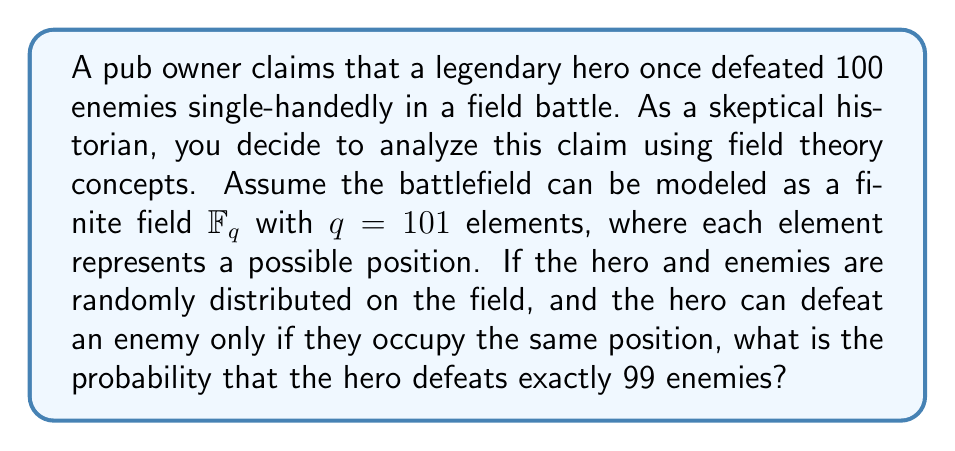Could you help me with this problem? Let's approach this step-by-step using concepts from field theory and probability:

1) The battlefield is modeled as a finite field $\mathbb{F}_{101}$ with 101 elements.

2) We need to calculate the probability of the hero occupying the same position as exactly 99 out of 100 enemies.

3) This scenario follows a binomial probability distribution, where:
   - $n = 100$ (total number of enemies)
   - $k = 99$ (number of enemies defeated)
   - $p = \frac{1}{101}$ (probability of an enemy being in the same position as the hero)

4) The probability mass function for a binomial distribution is:

   $$P(X = k) = \binom{n}{k} p^k (1-p)^{n-k}$$

5) Substituting our values:

   $$P(X = 99) = \binom{100}{99} (\frac{1}{101})^{99} (1-\frac{1}{101})^{100-99}$$

6) Simplify:
   
   $$P(X = 99) = 100 \cdot (\frac{1}{101})^{99} \cdot (\frac{100}{101})^1$$

7) Calculate:
   
   $$P(X = 99) \approx 9.2 \times 10^{-198}$$

This extremely small probability suggests that the pub owner's claim is highly unlikely to be true.
Answer: $9.2 \times 10^{-198}$ 